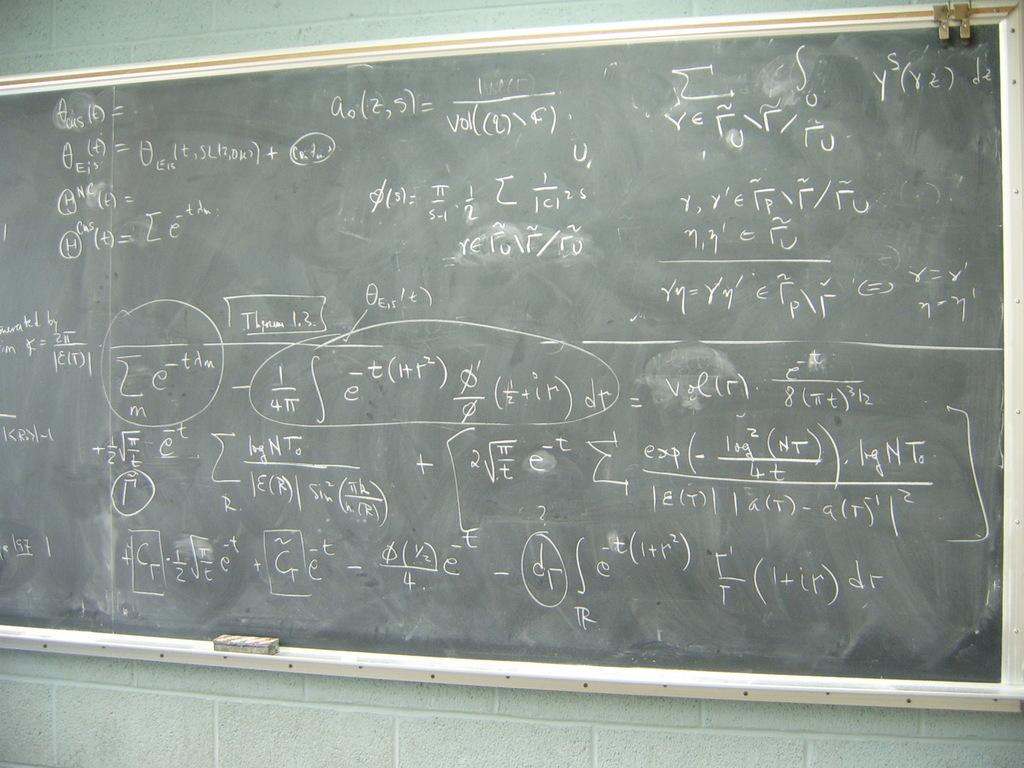<image>
Provide a brief description of the given image. Chalk board that include equations and fractions on it 